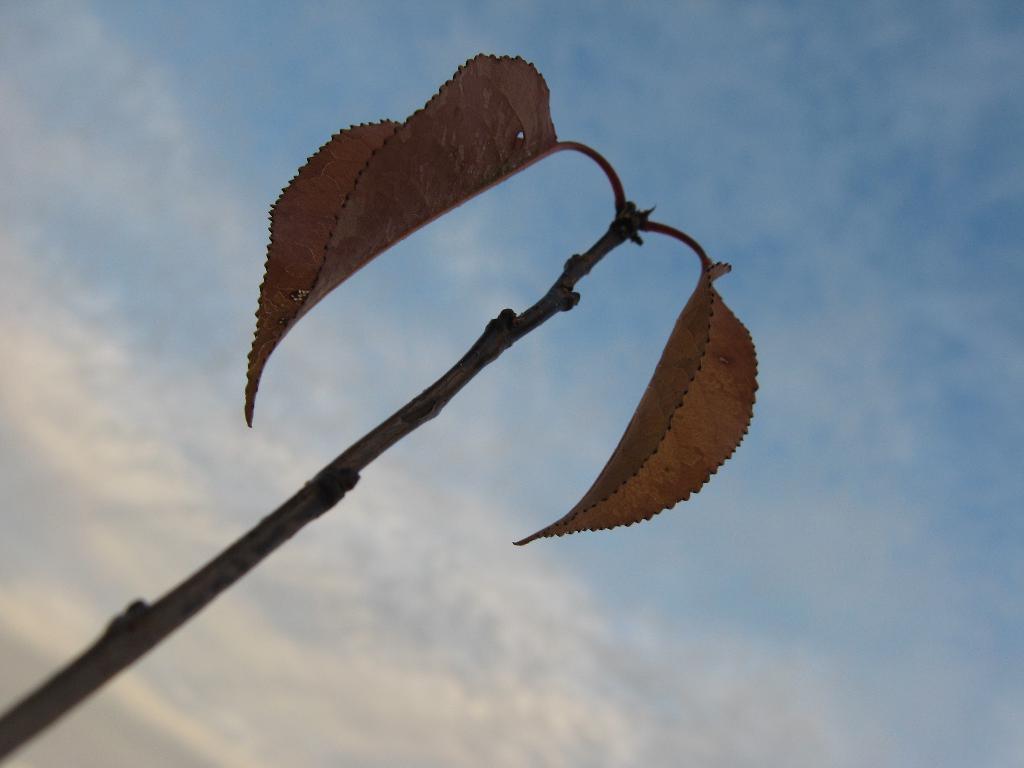Could you give a brief overview of what you see in this image? In the foreground of the picture there is a stem and there are leaves. Sky is bit cloudy. 